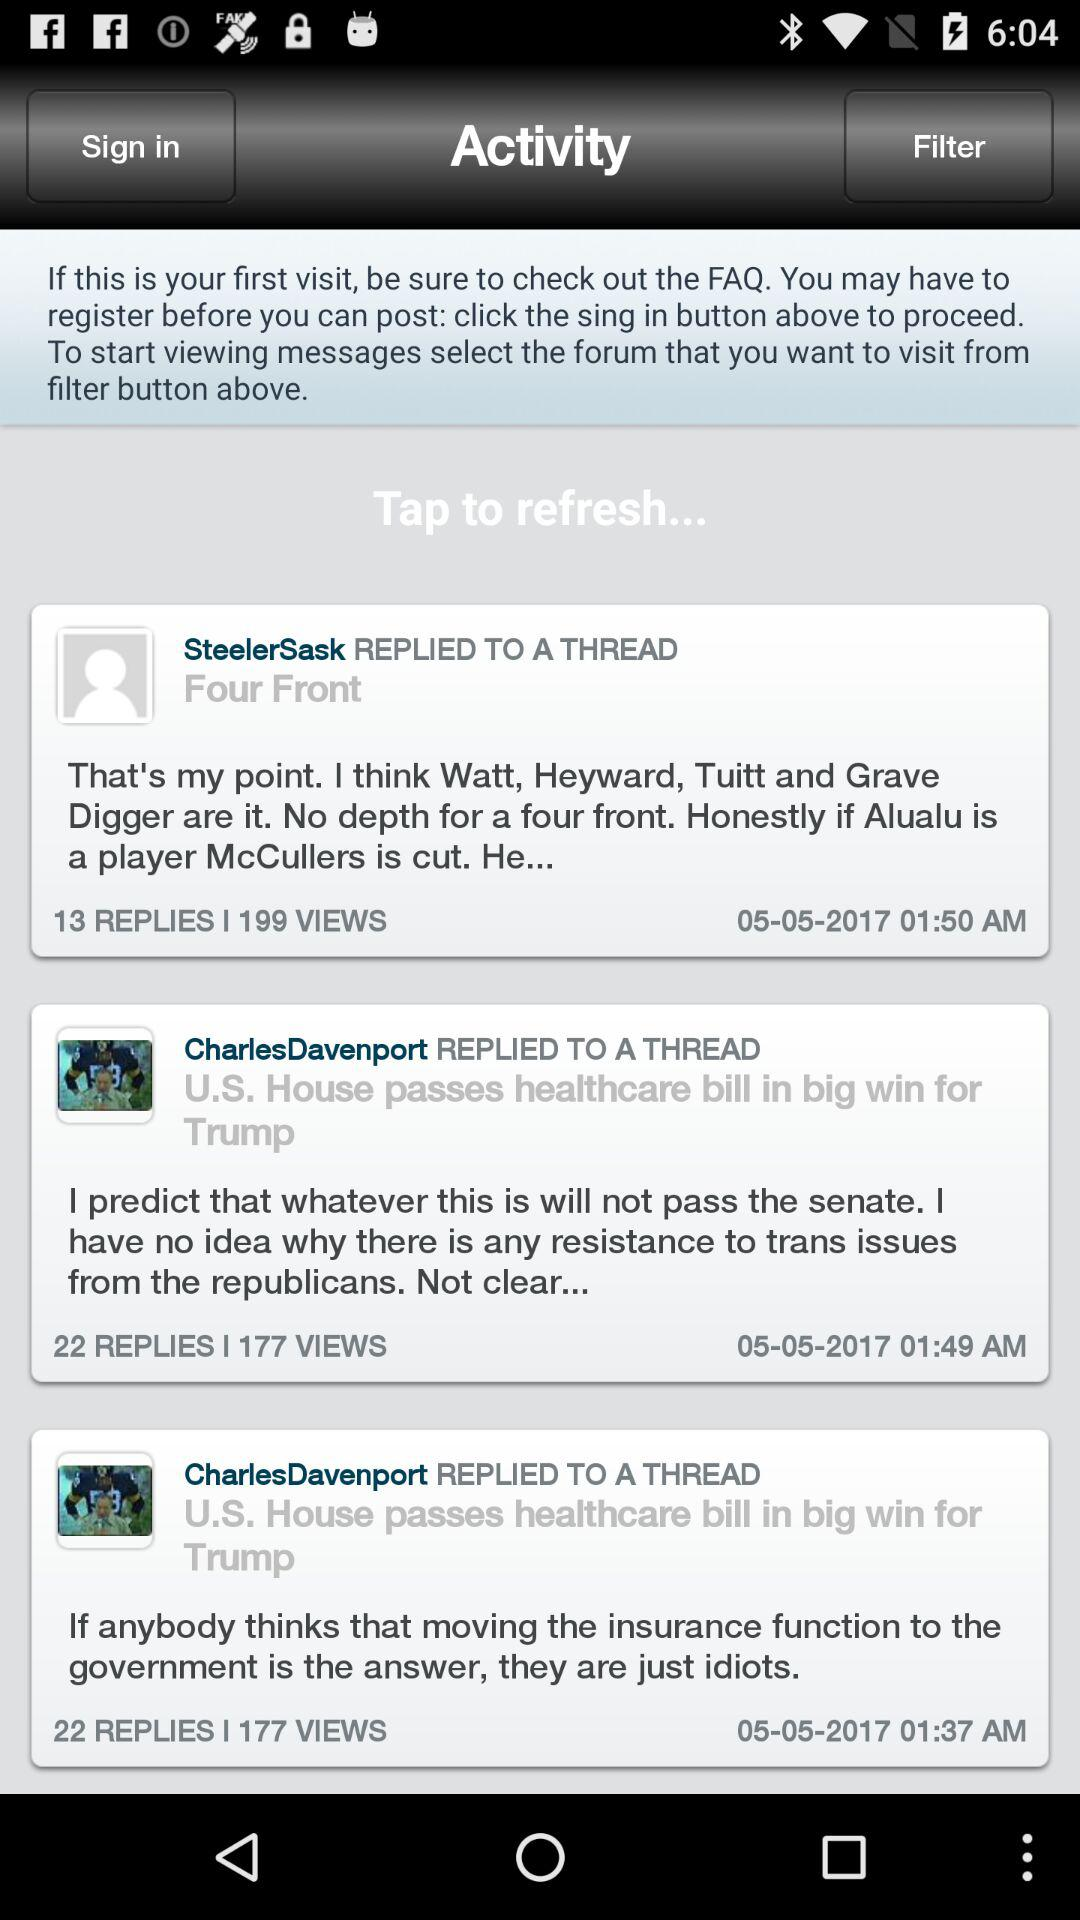At 1:49 a.m., who made the comment? At 1:49 a.m., Charles Davenport made the comment. 